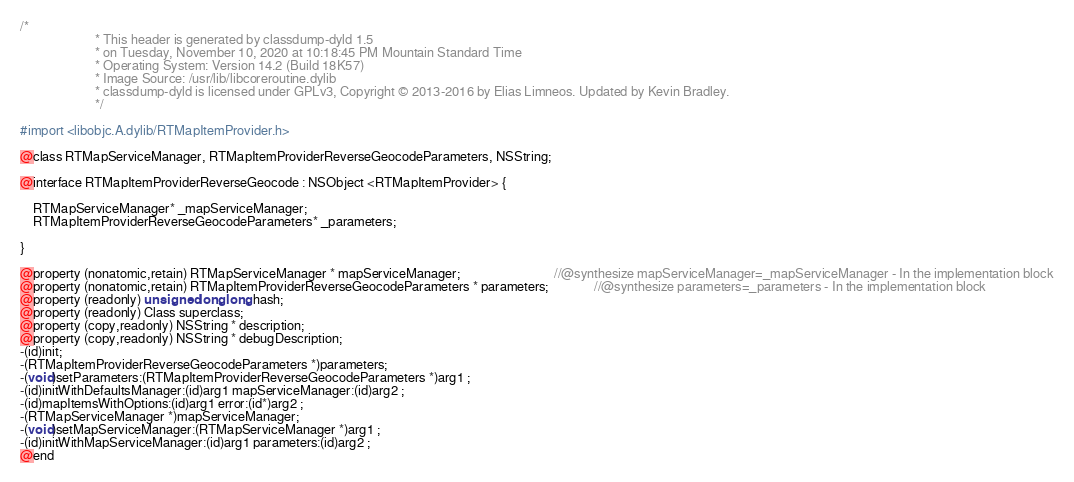Convert code to text. <code><loc_0><loc_0><loc_500><loc_500><_C_>/*
                       * This header is generated by classdump-dyld 1.5
                       * on Tuesday, November 10, 2020 at 10:18:45 PM Mountain Standard Time
                       * Operating System: Version 14.2 (Build 18K57)
                       * Image Source: /usr/lib/libcoreroutine.dylib
                       * classdump-dyld is licensed under GPLv3, Copyright © 2013-2016 by Elias Limneos. Updated by Kevin Bradley.
                       */

#import <libobjc.A.dylib/RTMapItemProvider.h>

@class RTMapServiceManager, RTMapItemProviderReverseGeocodeParameters, NSString;

@interface RTMapItemProviderReverseGeocode : NSObject <RTMapItemProvider> {

	RTMapServiceManager* _mapServiceManager;
	RTMapItemProviderReverseGeocodeParameters* _parameters;

}

@property (nonatomic,retain) RTMapServiceManager * mapServiceManager;                             //@synthesize mapServiceManager=_mapServiceManager - In the implementation block
@property (nonatomic,retain) RTMapItemProviderReverseGeocodeParameters * parameters;              //@synthesize parameters=_parameters - In the implementation block
@property (readonly) unsigned long long hash; 
@property (readonly) Class superclass; 
@property (copy,readonly) NSString * description; 
@property (copy,readonly) NSString * debugDescription; 
-(id)init;
-(RTMapItemProviderReverseGeocodeParameters *)parameters;
-(void)setParameters:(RTMapItemProviderReverseGeocodeParameters *)arg1 ;
-(id)initWithDefaultsManager:(id)arg1 mapServiceManager:(id)arg2 ;
-(id)mapItemsWithOptions:(id)arg1 error:(id*)arg2 ;
-(RTMapServiceManager *)mapServiceManager;
-(void)setMapServiceManager:(RTMapServiceManager *)arg1 ;
-(id)initWithMapServiceManager:(id)arg1 parameters:(id)arg2 ;
@end

</code> 